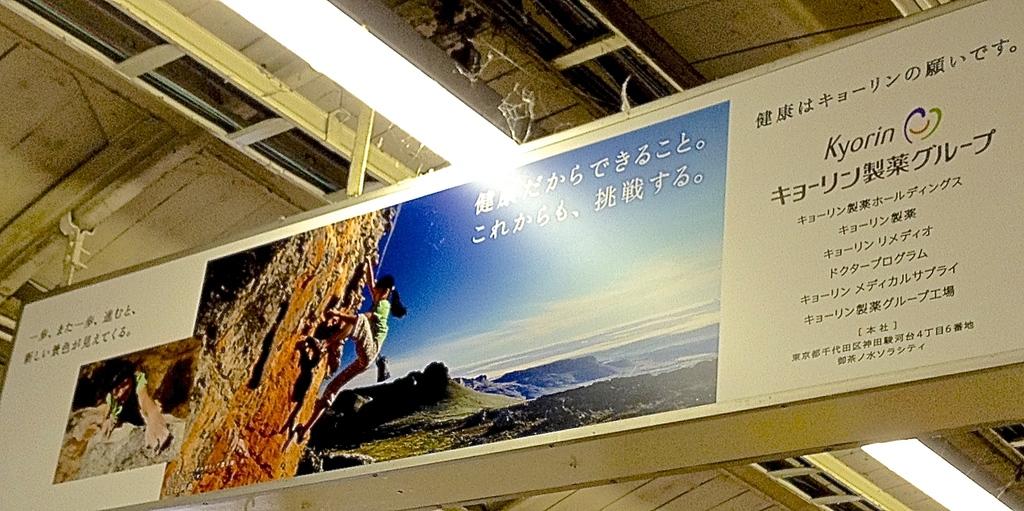What company is that banner for?
Give a very brief answer. Kyorin. 